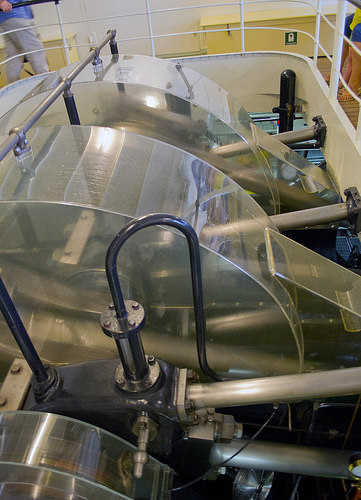<image>
Can you confirm if the woman is in front of the machine? Yes. The woman is positioned in front of the machine, appearing closer to the camera viewpoint. 